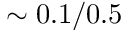Convert formula to latex. <formula><loc_0><loc_0><loc_500><loc_500>\sim 0 . 1 / 0 . 5</formula> 